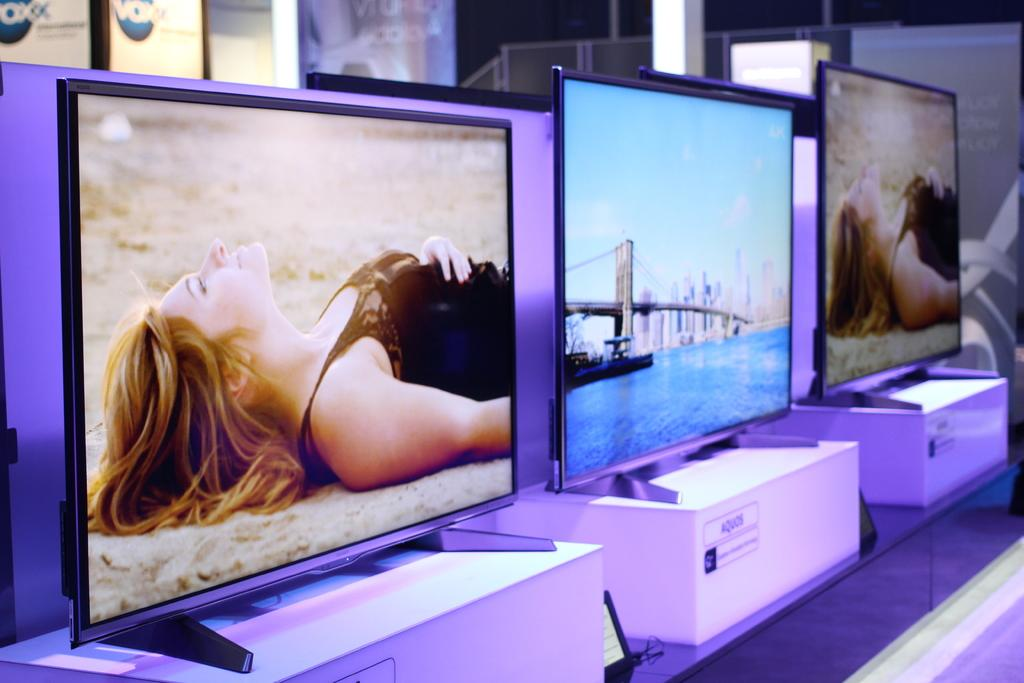<image>
Offer a succinct explanation of the picture presented. A row of flat screen TVs are on display and their stands have the brand name Aquios. 